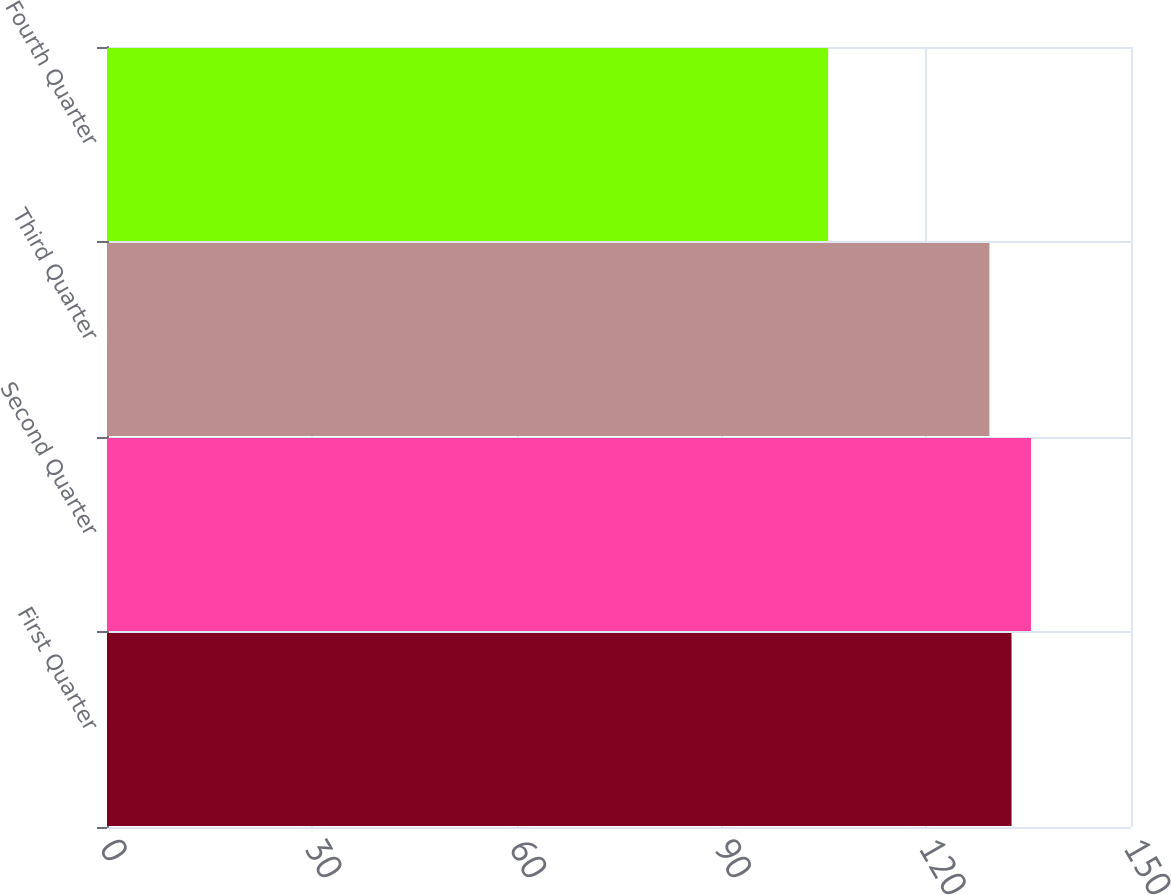Convert chart to OTSL. <chart><loc_0><loc_0><loc_500><loc_500><bar_chart><fcel>First Quarter<fcel>Second Quarter<fcel>Third Quarter<fcel>Fourth Quarter<nl><fcel>132.5<fcel>135.35<fcel>129.26<fcel>105.64<nl></chart> 